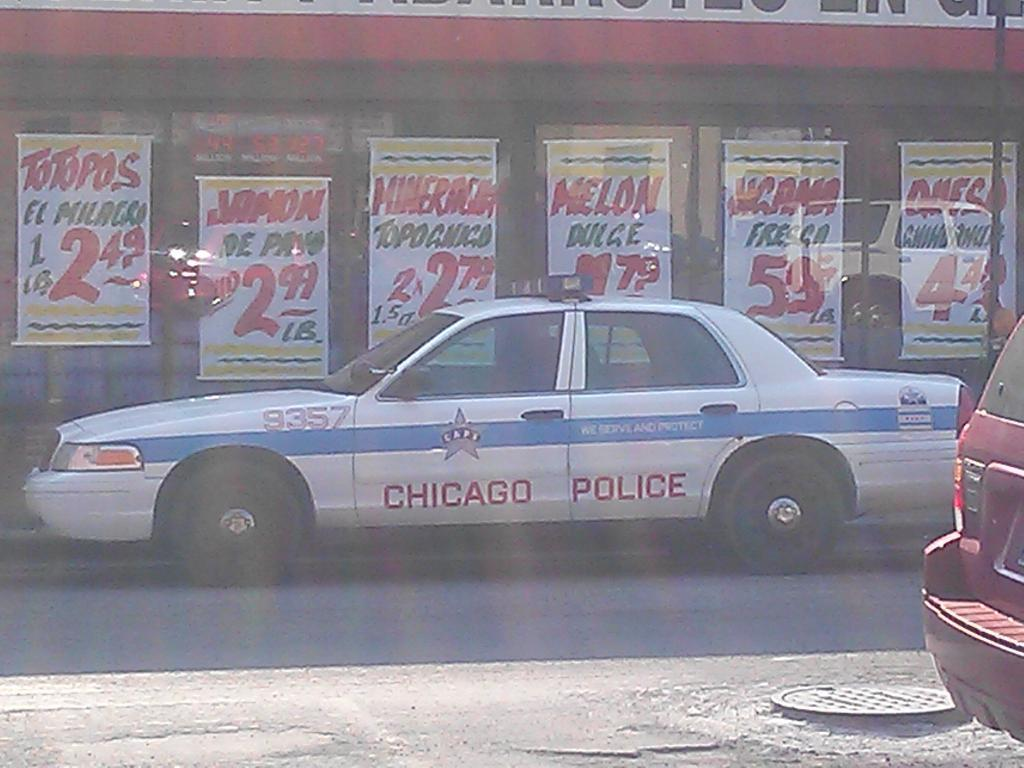What is the main subject of the image? The main subject of the image is a road. What can be seen on the road in the image? There are vehicles on the road in the image. Are there any additional elements in the image besides the road and vehicles? Yes, there are posters in the image. How many quince are being sold at the roadside in the image? There are no quince or any indication of a roadside sale in the image. Is there a hydrant visible on the side of the road in the image? There is no hydrant visible in the image. 